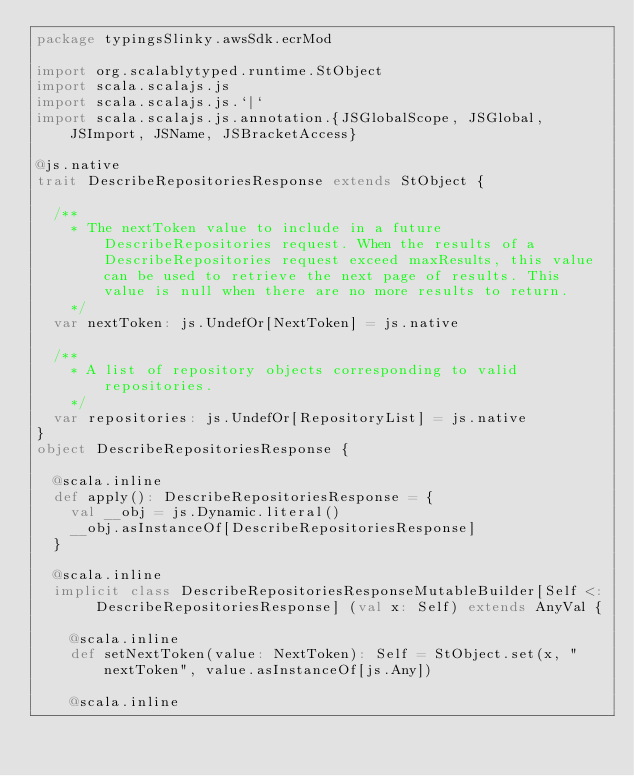Convert code to text. <code><loc_0><loc_0><loc_500><loc_500><_Scala_>package typingsSlinky.awsSdk.ecrMod

import org.scalablytyped.runtime.StObject
import scala.scalajs.js
import scala.scalajs.js.`|`
import scala.scalajs.js.annotation.{JSGlobalScope, JSGlobal, JSImport, JSName, JSBracketAccess}

@js.native
trait DescribeRepositoriesResponse extends StObject {
  
  /**
    * The nextToken value to include in a future DescribeRepositories request. When the results of a DescribeRepositories request exceed maxResults, this value can be used to retrieve the next page of results. This value is null when there are no more results to return.
    */
  var nextToken: js.UndefOr[NextToken] = js.native
  
  /**
    * A list of repository objects corresponding to valid repositories.
    */
  var repositories: js.UndefOr[RepositoryList] = js.native
}
object DescribeRepositoriesResponse {
  
  @scala.inline
  def apply(): DescribeRepositoriesResponse = {
    val __obj = js.Dynamic.literal()
    __obj.asInstanceOf[DescribeRepositoriesResponse]
  }
  
  @scala.inline
  implicit class DescribeRepositoriesResponseMutableBuilder[Self <: DescribeRepositoriesResponse] (val x: Self) extends AnyVal {
    
    @scala.inline
    def setNextToken(value: NextToken): Self = StObject.set(x, "nextToken", value.asInstanceOf[js.Any])
    
    @scala.inline</code> 